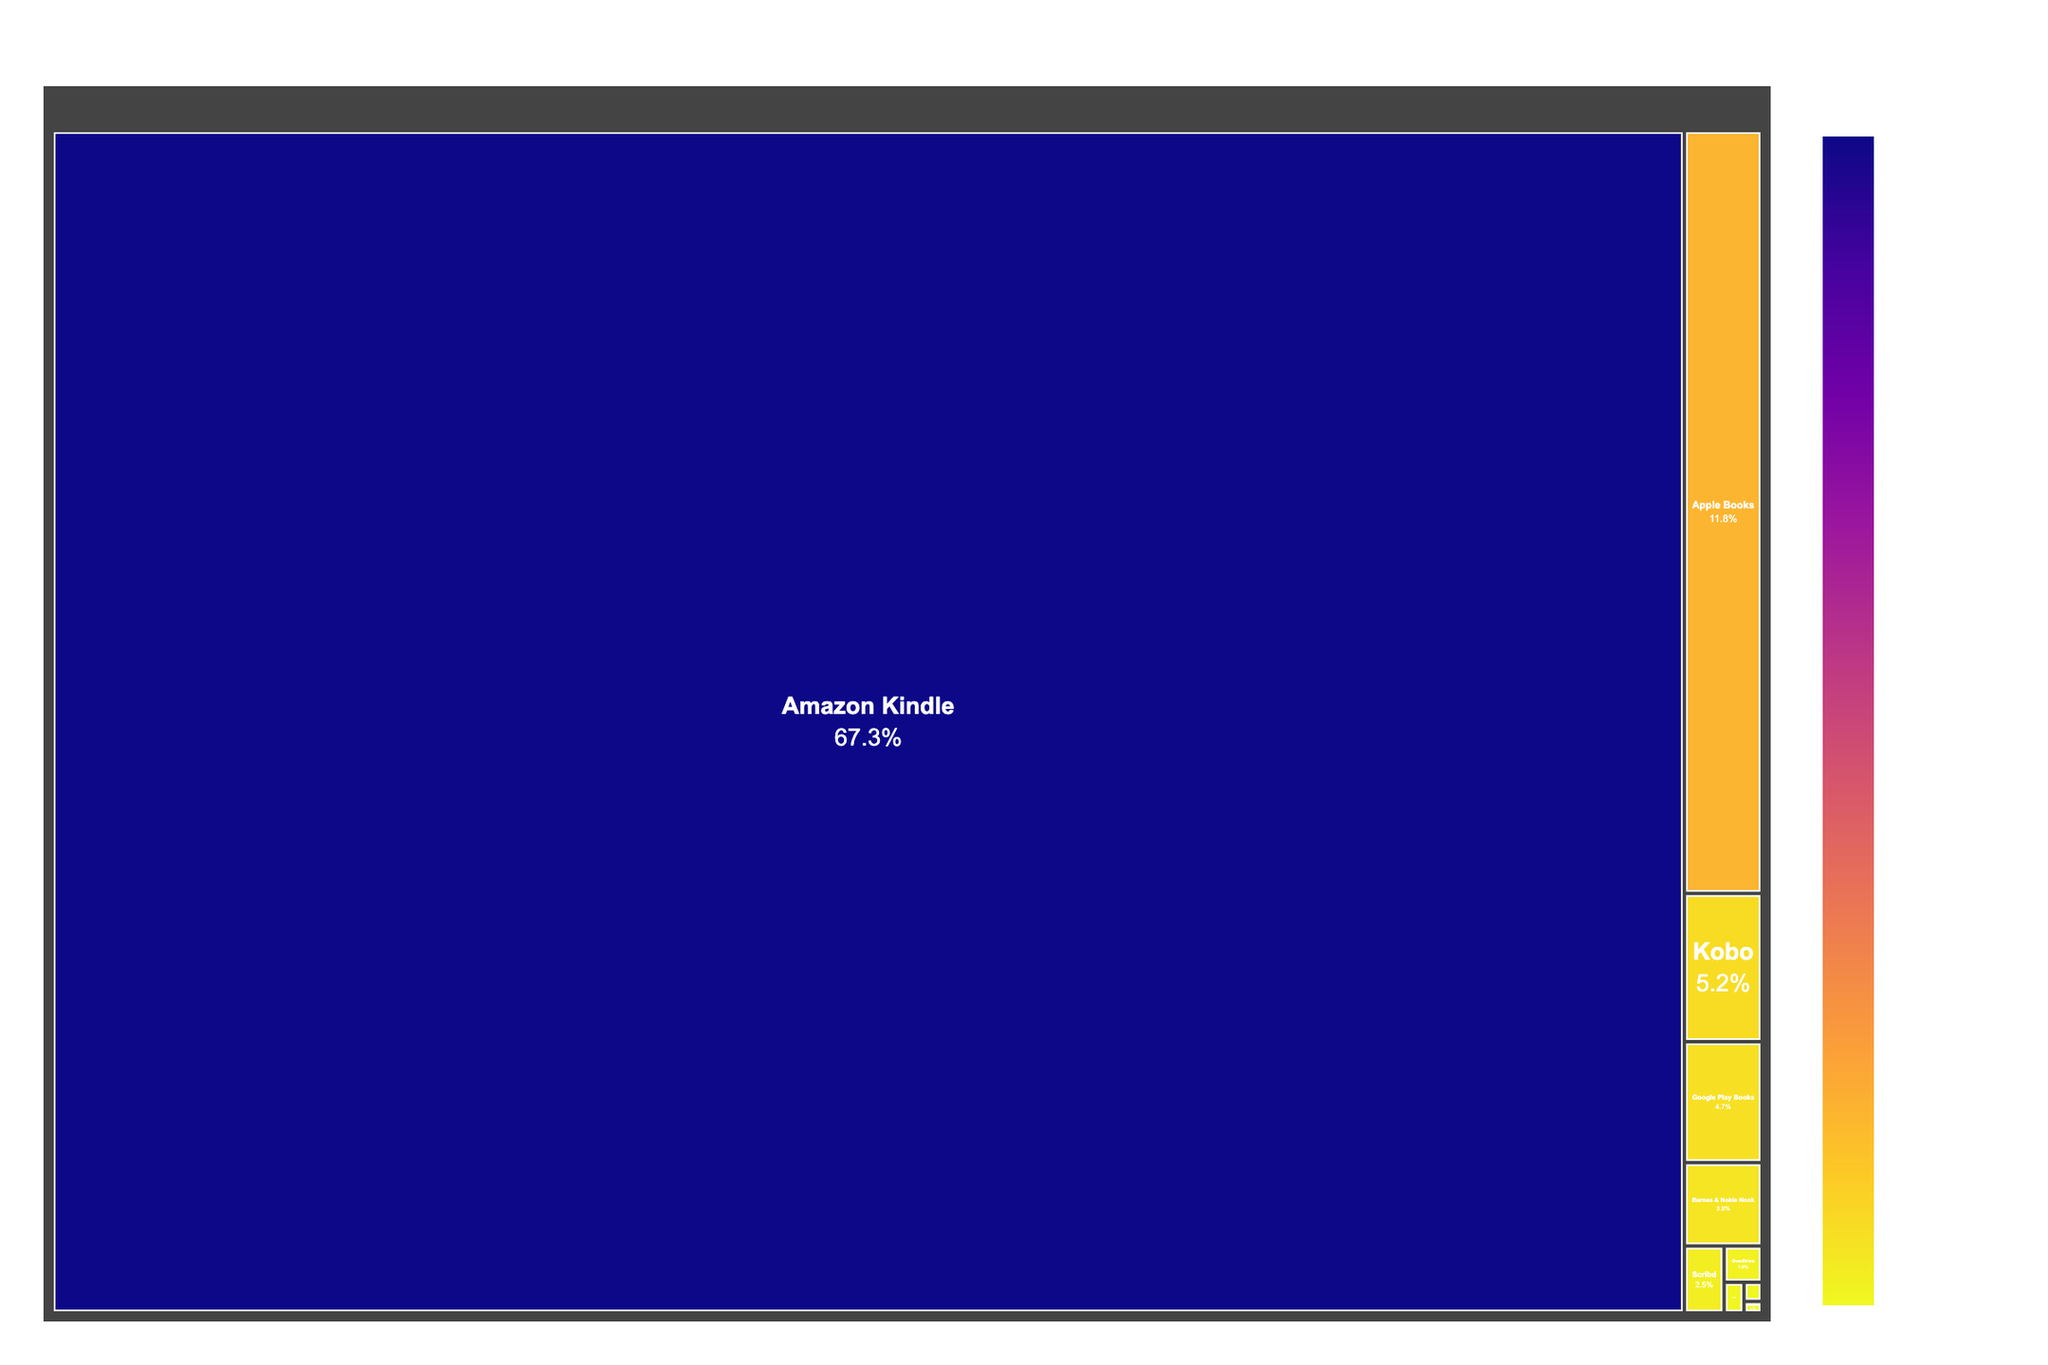What's the title of the figure? Look at the top of the figure where the title is displayed.
Answer: eBook Platform Market Share Which platform has the largest market share? Identify the largest section in the treemap, which is usually visually the most prominent.
Answer: Amazon Kindle What is the market share of Apple Books? Find the section labeled Apple Books in the treemap and look at the associated percentage.
Answer: 11.8% What is the combined market share of Kobo and Google Play Books? Locate the sections for Kobo and Google Play Books, then add their market shares: 5.2% + 4.7%.
Answer: 9.9% Which platform has the smallest market share? Identify the smallest section in the treemap, which is the segment with the smallest area.
Answer: Storytel How many platforms have a market share above 5%? Count the number of sections in the treemap with a market share larger than 5%.
Answer: 2 Does Barnes & Noble Nook have a larger market share than Scribd? Compare the market shares of Barnes & Noble Nook (3.9%) and Scribd (2.5%).
Answer: Yes What is the difference in market share between Amazon Kindle and the second largest platform? Subtract the market share of the second largest platform (Apple Books, 11.8%) from Amazon Kindle's market share (67.3%).
Answer: 55.5% Which two platforms combined have a market share closest to that of Amazon Kindle? Calculate the combined market shares of various platform pairs and find the pair closest to 67.3%. The combined market share of Apple Books (11.8%) and all other platforms individually is not significant enough to approach 67.3%, so search for the two largest subsequent platforms: Apple Books (11.8%) and Kobo (5.2%) which results in (11.8% + 5.2% = 17.0%). Continue analyzing larger combinations until the closest total is found.
Answer: No two platforms have a combined market share close to Amazon Kindle What is the average market share of the platforms excluding Amazon Kindle? First, sum the market shares of all other platforms and divide by the number of these platforms: (11.8 + 5.2 + 4.7 + 3.9 + 2.5 + 1.8 + 1.2 + 0.9 + 0.7) / 9.
Answer: 3.93 